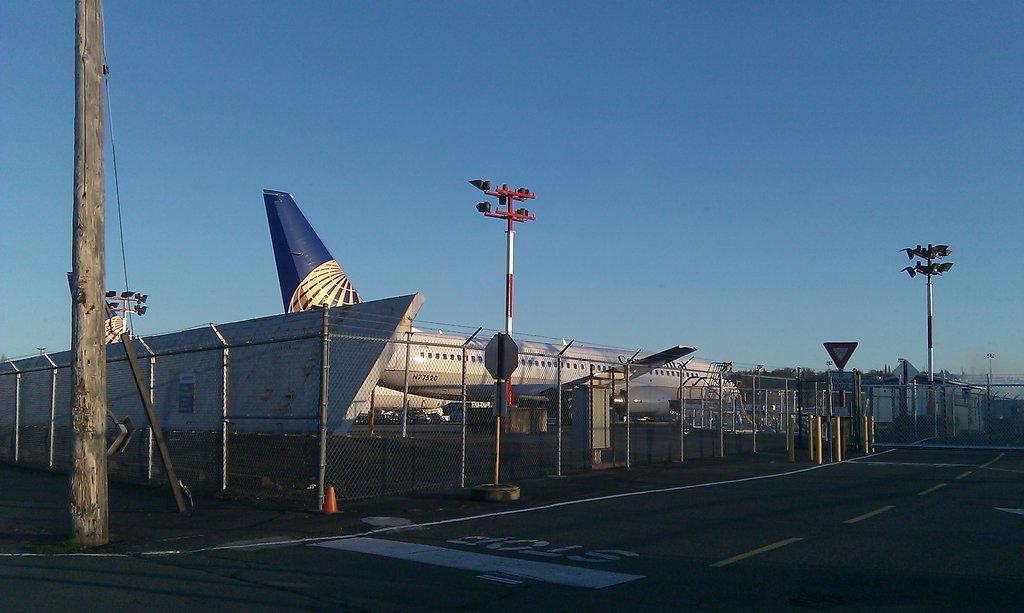Could you give a brief overview of what you see in this image? In this image I can see a metal grill beside a runway through which I can see an airplane standing. I can see some light poles and some sign boards I can see a wooden pole on the left hand side. 